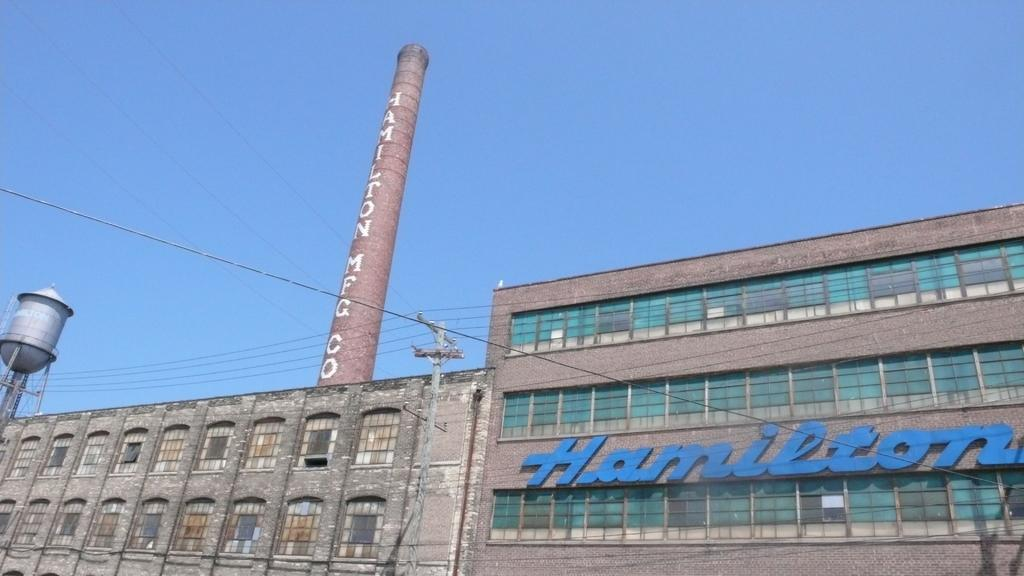What type of structures are visible in the image? There are buildings with windows in the image. What else can be seen in the image besides the buildings? There are wires, a pole, and a tower visible in the image. What is visible in the background of the image? The sky is visible in the background of the image. What type of silver muscle can be heard in the image? There is no silver muscle present in the image, and therefore no such sound can be heard. 